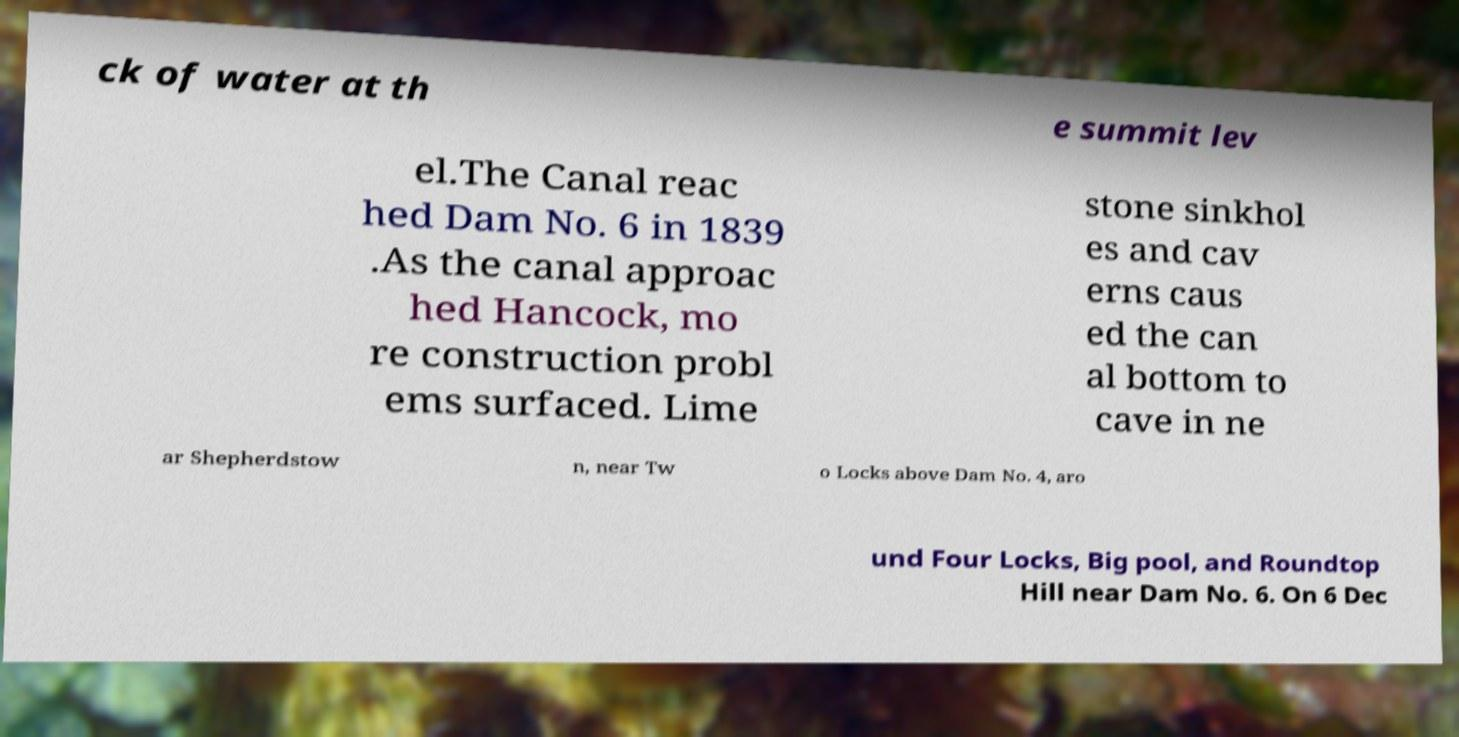Could you assist in decoding the text presented in this image and type it out clearly? ck of water at th e summit lev el.The Canal reac hed Dam No. 6 in 1839 .As the canal approac hed Hancock, mo re construction probl ems surfaced. Lime stone sinkhol es and cav erns caus ed the can al bottom to cave in ne ar Shepherdstow n, near Tw o Locks above Dam No. 4, aro und Four Locks, Big pool, and Roundtop Hill near Dam No. 6. On 6 Dec 